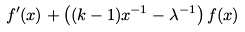<formula> <loc_0><loc_0><loc_500><loc_500>f ^ { \prime } ( x ) + \left ( ( k - 1 ) x ^ { - 1 } - \lambda ^ { - 1 } \right ) f ( x )</formula> 